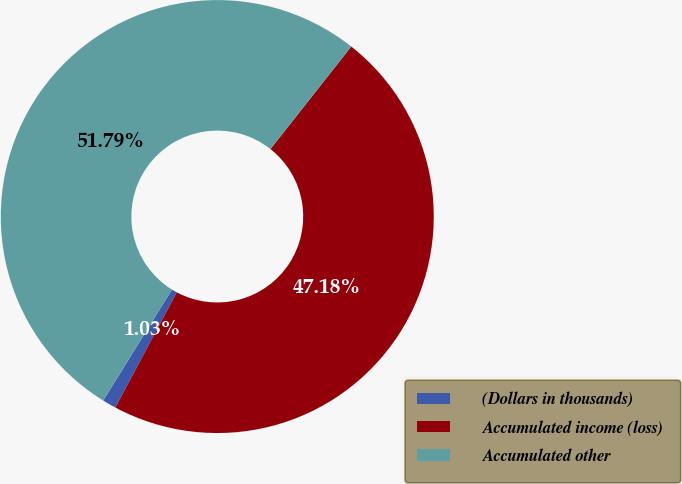Convert chart to OTSL. <chart><loc_0><loc_0><loc_500><loc_500><pie_chart><fcel>(Dollars in thousands)<fcel>Accumulated income (loss)<fcel>Accumulated other<nl><fcel>1.03%<fcel>47.18%<fcel>51.79%<nl></chart> 